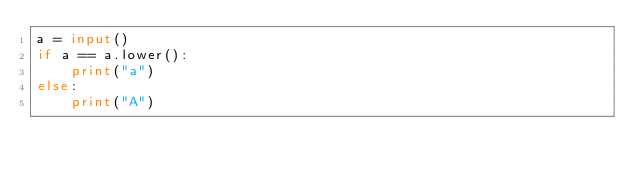Convert code to text. <code><loc_0><loc_0><loc_500><loc_500><_Python_>a = input()
if a == a.lower():
    print("a")
else:
    print("A")</code> 